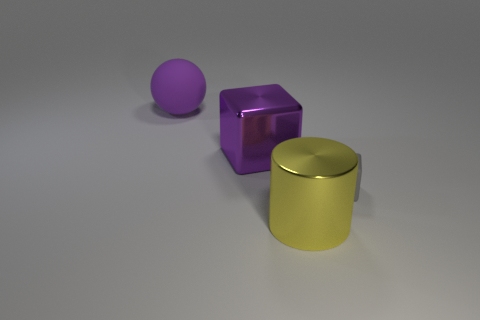Add 3 small cyan metal cylinders. How many objects exist? 7 Subtract all spheres. How many objects are left? 3 Add 3 cylinders. How many cylinders are left? 4 Add 1 large green matte spheres. How many large green matte spheres exist? 1 Subtract 0 cyan cylinders. How many objects are left? 4 Subtract all big purple shiny cubes. Subtract all big purple cubes. How many objects are left? 2 